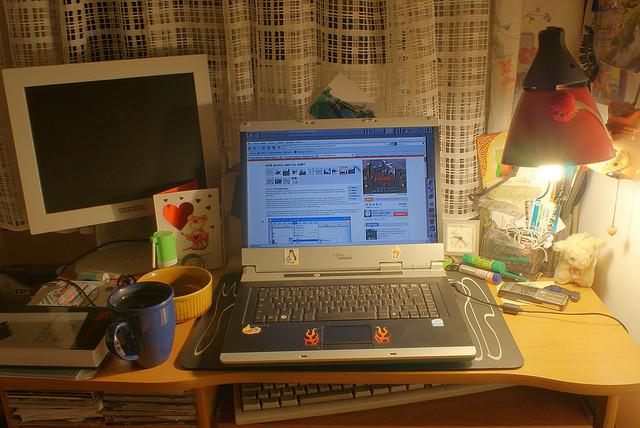What color is the mug?
Write a very short answer. Blue. How many screens are on?
Concise answer only. 1. Where is the coffee mug?
Answer briefly. On desk. Is this a MAC?
Be succinct. No. 